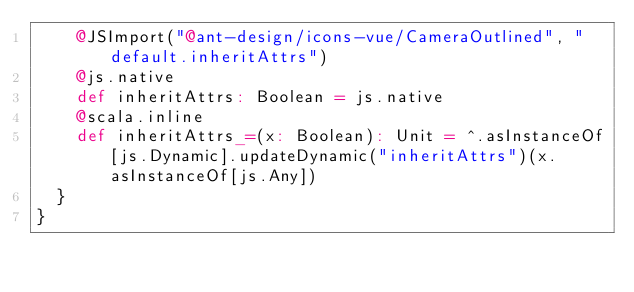Convert code to text. <code><loc_0><loc_0><loc_500><loc_500><_Scala_>    @JSImport("@ant-design/icons-vue/CameraOutlined", "default.inheritAttrs")
    @js.native
    def inheritAttrs: Boolean = js.native
    @scala.inline
    def inheritAttrs_=(x: Boolean): Unit = ^.asInstanceOf[js.Dynamic].updateDynamic("inheritAttrs")(x.asInstanceOf[js.Any])
  }
}
</code> 